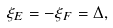<formula> <loc_0><loc_0><loc_500><loc_500>\xi _ { E } & = - \xi _ { F } = \Delta ,</formula> 